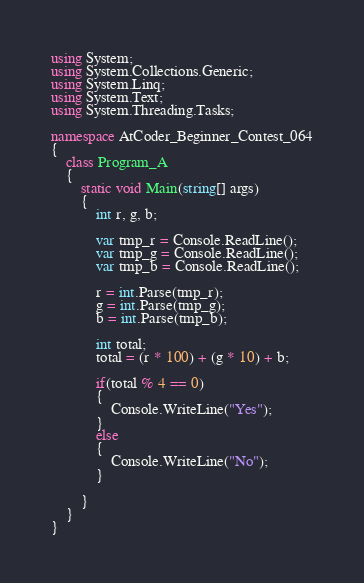Convert code to text. <code><loc_0><loc_0><loc_500><loc_500><_C#_>using System;
using System.Collections.Generic;
using System.Linq;
using System.Text;
using System.Threading.Tasks;

namespace AtCoder_Beginner_Contest_064
{
    class Program_A
    {
        static void Main(string[] args)
        {
            int r, g, b;

            var tmp_r = Console.ReadLine();
            var tmp_g = Console.ReadLine();
            var tmp_b = Console.ReadLine();

            r = int.Parse(tmp_r);
            g = int.Parse(tmp_g);
            b = int.Parse(tmp_b);

            int total;
            total = (r * 100) + (g * 10) + b;

            if(total % 4 == 0)
            {
                Console.WriteLine("Yes");
            }
            else
            {
                Console.WriteLine("No");
            }

        }
    }
}
</code> 